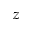Convert formula to latex. <formula><loc_0><loc_0><loc_500><loc_500>z</formula> 